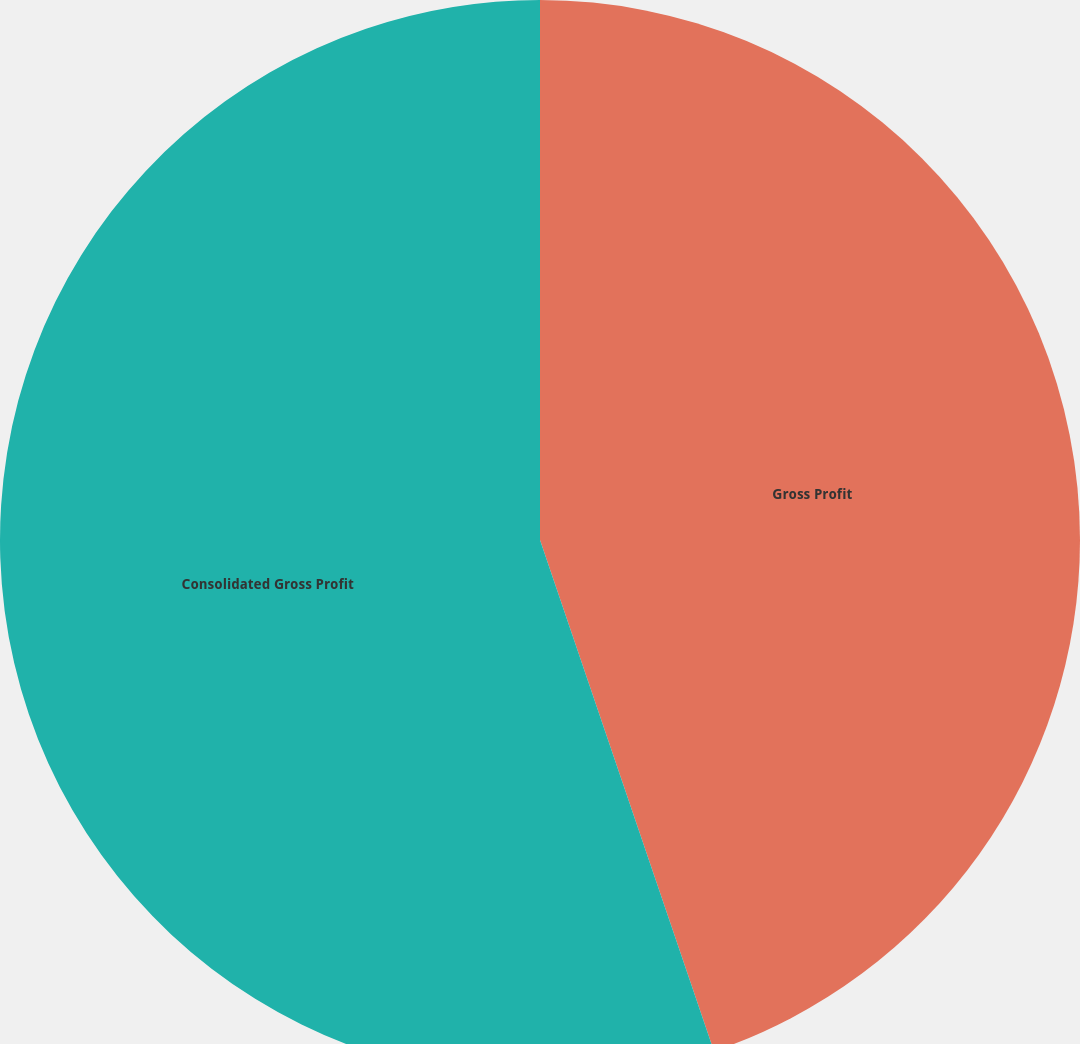Convert chart to OTSL. <chart><loc_0><loc_0><loc_500><loc_500><pie_chart><fcel>Gross Profit<fcel>Consolidated Gross Profit<nl><fcel>44.78%<fcel>55.22%<nl></chart> 